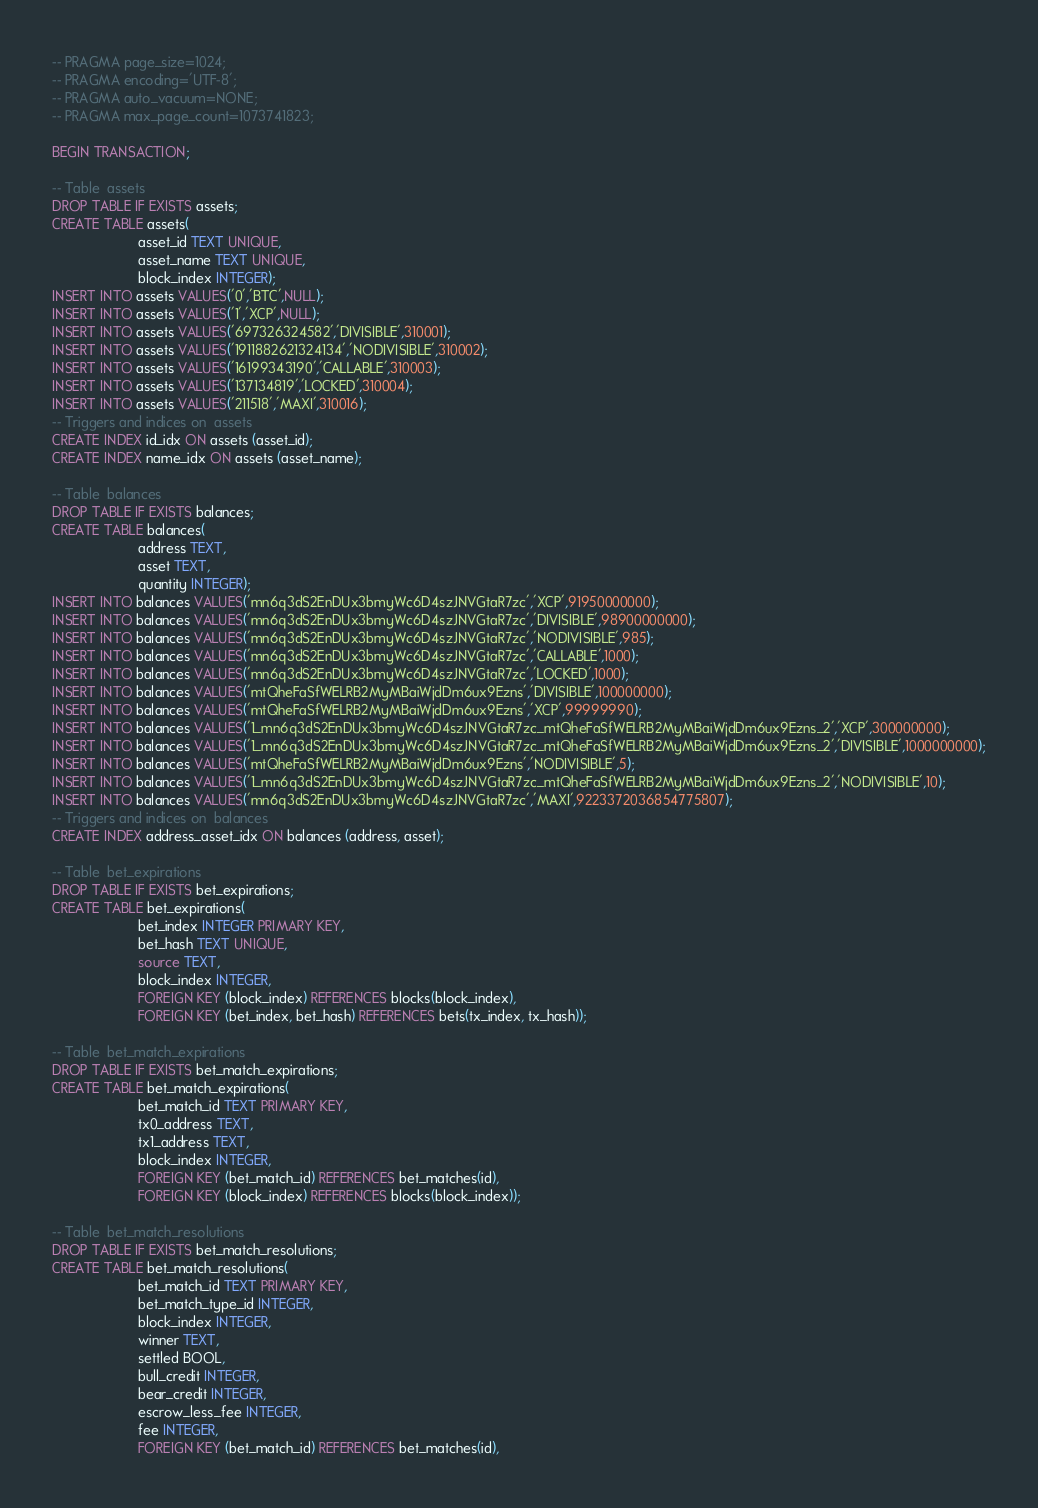Convert code to text. <code><loc_0><loc_0><loc_500><loc_500><_SQL_>-- PRAGMA page_size=1024;
-- PRAGMA encoding='UTF-8';
-- PRAGMA auto_vacuum=NONE;
-- PRAGMA max_page_count=1073741823;

BEGIN TRANSACTION;

-- Table  assets
DROP TABLE IF EXISTS assets;
CREATE TABLE assets(
                      asset_id TEXT UNIQUE,
                      asset_name TEXT UNIQUE,
                      block_index INTEGER);
INSERT INTO assets VALUES('0','BTC',NULL);
INSERT INTO assets VALUES('1','XCP',NULL);
INSERT INTO assets VALUES('697326324582','DIVISIBLE',310001);
INSERT INTO assets VALUES('1911882621324134','NODIVISIBLE',310002);
INSERT INTO assets VALUES('16199343190','CALLABLE',310003);
INSERT INTO assets VALUES('137134819','LOCKED',310004);
INSERT INTO assets VALUES('211518','MAXI',310016);
-- Triggers and indices on  assets
CREATE INDEX id_idx ON assets (asset_id);
CREATE INDEX name_idx ON assets (asset_name);

-- Table  balances
DROP TABLE IF EXISTS balances;
CREATE TABLE balances(
                      address TEXT,
                      asset TEXT,
                      quantity INTEGER);
INSERT INTO balances VALUES('mn6q3dS2EnDUx3bmyWc6D4szJNVGtaR7zc','XCP',91950000000);
INSERT INTO balances VALUES('mn6q3dS2EnDUx3bmyWc6D4szJNVGtaR7zc','DIVISIBLE',98900000000);
INSERT INTO balances VALUES('mn6q3dS2EnDUx3bmyWc6D4szJNVGtaR7zc','NODIVISIBLE',985);
INSERT INTO balances VALUES('mn6q3dS2EnDUx3bmyWc6D4szJNVGtaR7zc','CALLABLE',1000);
INSERT INTO balances VALUES('mn6q3dS2EnDUx3bmyWc6D4szJNVGtaR7zc','LOCKED',1000);
INSERT INTO balances VALUES('mtQheFaSfWELRB2MyMBaiWjdDm6ux9Ezns','DIVISIBLE',100000000);
INSERT INTO balances VALUES('mtQheFaSfWELRB2MyMBaiWjdDm6ux9Ezns','XCP',99999990);
INSERT INTO balances VALUES('1_mn6q3dS2EnDUx3bmyWc6D4szJNVGtaR7zc_mtQheFaSfWELRB2MyMBaiWjdDm6ux9Ezns_2','XCP',300000000);
INSERT INTO balances VALUES('1_mn6q3dS2EnDUx3bmyWc6D4szJNVGtaR7zc_mtQheFaSfWELRB2MyMBaiWjdDm6ux9Ezns_2','DIVISIBLE',1000000000);
INSERT INTO balances VALUES('mtQheFaSfWELRB2MyMBaiWjdDm6ux9Ezns','NODIVISIBLE',5);
INSERT INTO balances VALUES('1_mn6q3dS2EnDUx3bmyWc6D4szJNVGtaR7zc_mtQheFaSfWELRB2MyMBaiWjdDm6ux9Ezns_2','NODIVISIBLE',10);
INSERT INTO balances VALUES('mn6q3dS2EnDUx3bmyWc6D4szJNVGtaR7zc','MAXI',9223372036854775807);
-- Triggers and indices on  balances
CREATE INDEX address_asset_idx ON balances (address, asset);

-- Table  bet_expirations
DROP TABLE IF EXISTS bet_expirations;
CREATE TABLE bet_expirations(
                      bet_index INTEGER PRIMARY KEY,
                      bet_hash TEXT UNIQUE,
                      source TEXT,
                      block_index INTEGER,
                      FOREIGN KEY (block_index) REFERENCES blocks(block_index),
                      FOREIGN KEY (bet_index, bet_hash) REFERENCES bets(tx_index, tx_hash));

-- Table  bet_match_expirations
DROP TABLE IF EXISTS bet_match_expirations;
CREATE TABLE bet_match_expirations(
                      bet_match_id TEXT PRIMARY KEY,
                      tx0_address TEXT,
                      tx1_address TEXT,
                      block_index INTEGER,
                      FOREIGN KEY (bet_match_id) REFERENCES bet_matches(id),
                      FOREIGN KEY (block_index) REFERENCES blocks(block_index));

-- Table  bet_match_resolutions
DROP TABLE IF EXISTS bet_match_resolutions;
CREATE TABLE bet_match_resolutions(
                      bet_match_id TEXT PRIMARY KEY,
                      bet_match_type_id INTEGER,
                      block_index INTEGER,
                      winner TEXT,
                      settled BOOL,
                      bull_credit INTEGER,
                      bear_credit INTEGER,
                      escrow_less_fee INTEGER,
                      fee INTEGER,
                      FOREIGN KEY (bet_match_id) REFERENCES bet_matches(id),</code> 